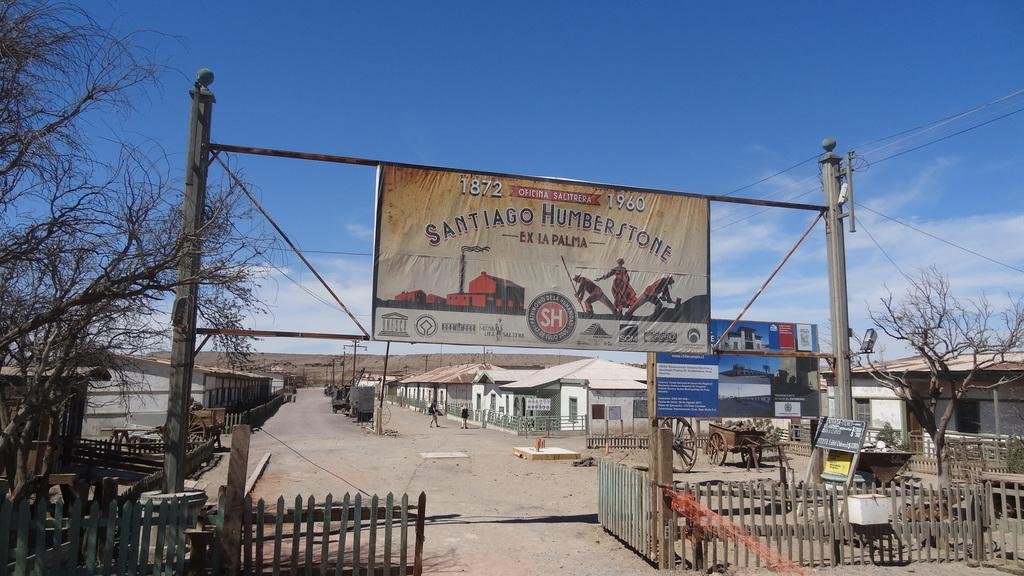<image>
Provide a brief description of the given image. Sign for an area saying "Santiago Humberstone" on it. 